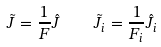<formula> <loc_0><loc_0><loc_500><loc_500>\tilde { J } = \frac { 1 } { F } \hat { J } \quad \tilde { J } _ { i } = \frac { 1 } { F _ { i } } \hat { J } _ { i }</formula> 